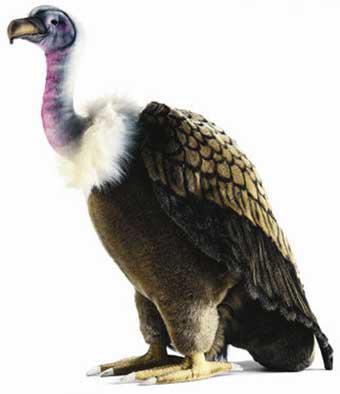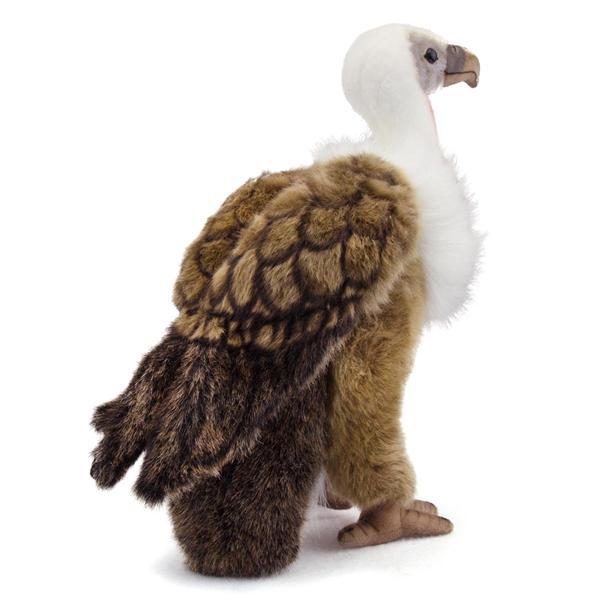The first image is the image on the left, the second image is the image on the right. Analyze the images presented: Is the assertion "1 bird is facing left and 1 bird is facing right." valid? Answer yes or no. Yes. 